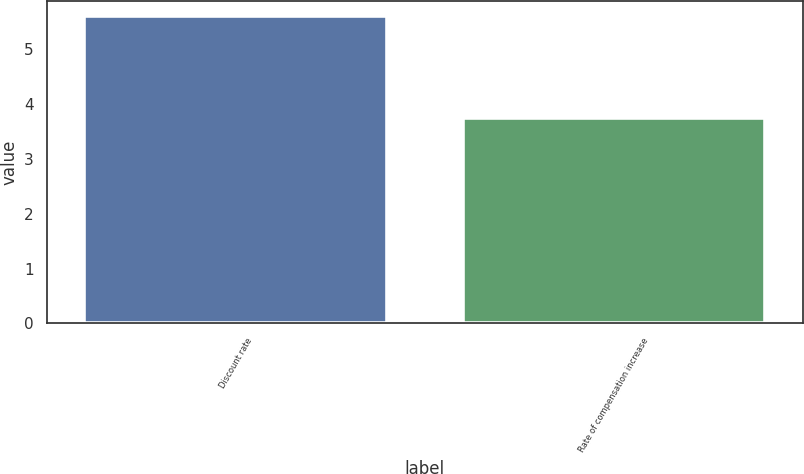Convert chart to OTSL. <chart><loc_0><loc_0><loc_500><loc_500><bar_chart><fcel>Discount rate<fcel>Rate of compensation increase<nl><fcel>5.6<fcel>3.75<nl></chart> 